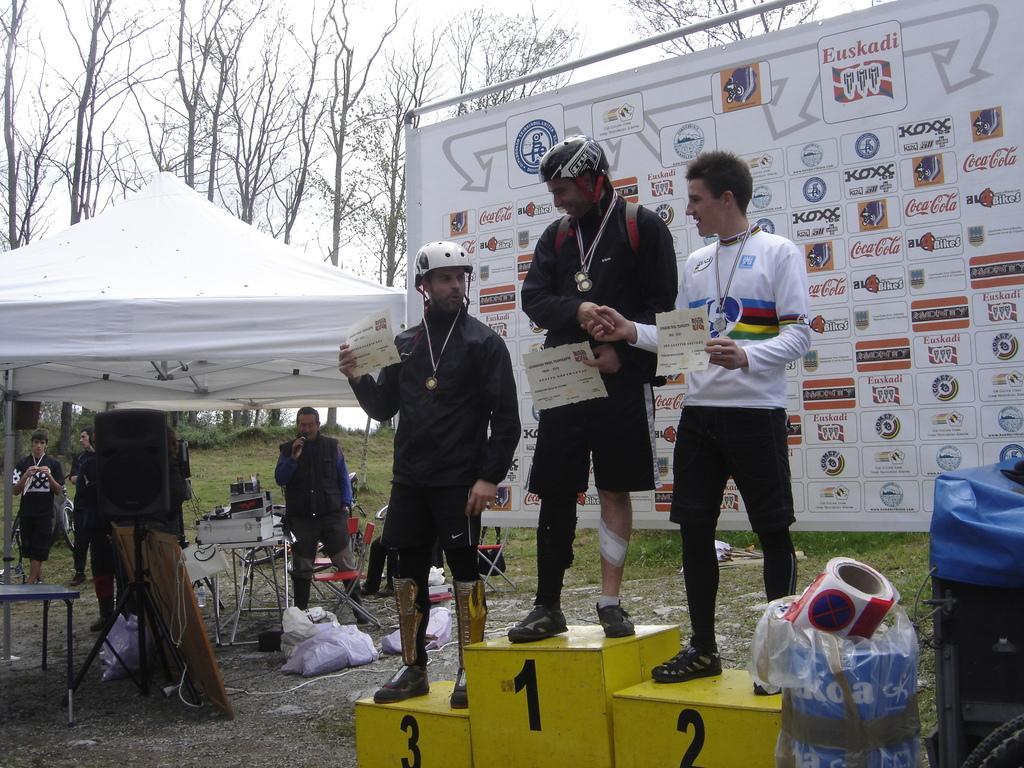Could you give a brief overview of what you see in this image? In this picture I see a yellow color thing on which there are numbers and I see 3 men who are standing on it and I see that they are holding papers in their hands. In the background I see a banner on which there are number of logos and something is written and on the right side of this picture I see few things. On the left side of this picture I see a tent and under it I see tables on which there are few things and I see people. On the top of this image I see number of trees. 